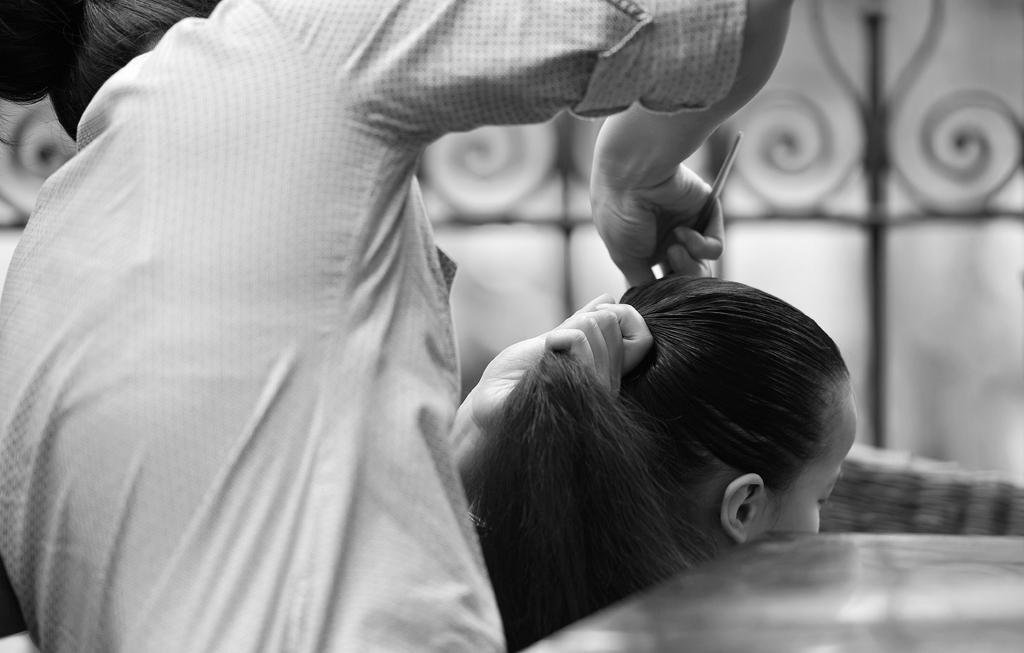What is the color scheme of the image? The image is black and white. What is happening in the image? There is a person in the image who is combing the hair of a woman. How is the woman positioned in relation to the person? The woman is sitting in front of the person. What can be seen in the background of the image? There is a fence visible in the background of the image. What type of guitar is the person playing in the image? There is no guitar present in the image; it features a person combing the hair of a woman. What kind of trouble is the woman experiencing in the image? There is no indication of trouble in the image; the woman is simply sitting while her hair is being combed. 